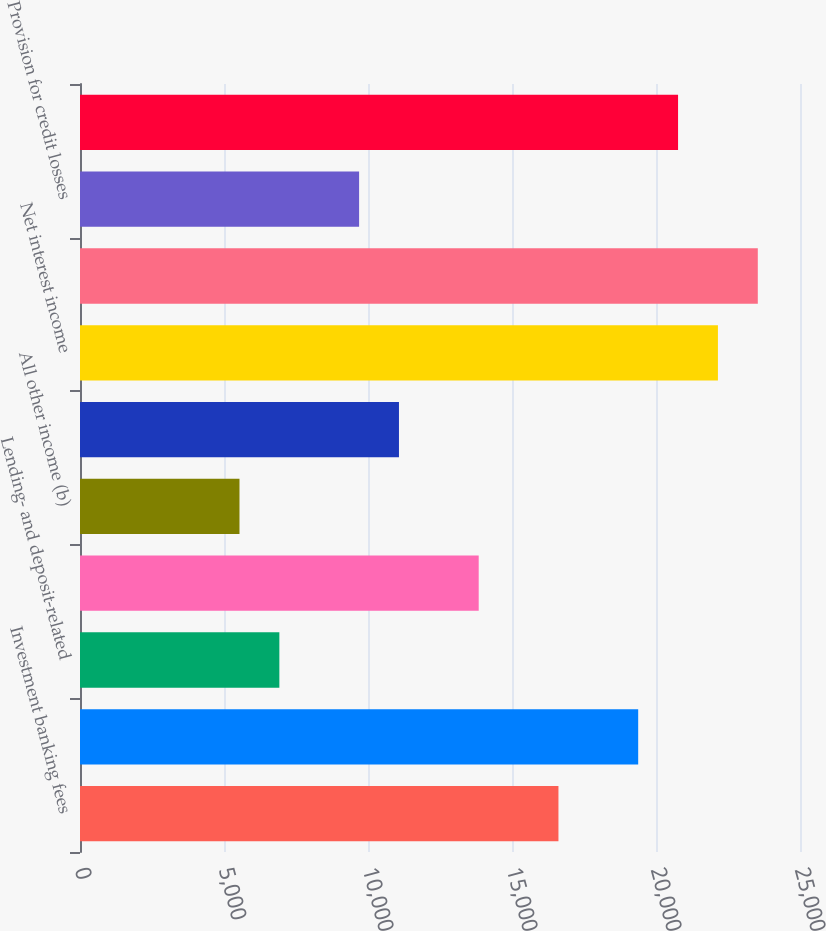Convert chart to OTSL. <chart><loc_0><loc_0><loc_500><loc_500><bar_chart><fcel>Investment banking fees<fcel>Principal transactions (a)<fcel>Lending- and deposit-related<fcel>Asset management<fcel>All other income (b)<fcel>Noninterest revenue<fcel>Net interest income<fcel>Total net revenue (c)<fcel>Provision for credit losses<fcel>Compensation expense<nl><fcel>16612.8<fcel>19381.6<fcel>6922.09<fcel>13844<fcel>5537.7<fcel>11075.3<fcel>22150.4<fcel>23534.8<fcel>9690.87<fcel>20766<nl></chart> 